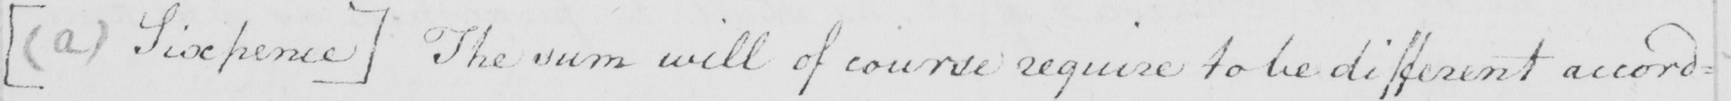What is written in this line of handwriting? [  ( a )  Sixpence ]  The sum will of course require to be different accord= 